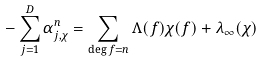Convert formula to latex. <formula><loc_0><loc_0><loc_500><loc_500>- \sum _ { j = 1 } ^ { D } \alpha _ { j , \chi } ^ { n } = \sum _ { \deg f = n } \Lambda ( f ) \chi ( f ) + \lambda _ { \infty } ( \chi )</formula> 